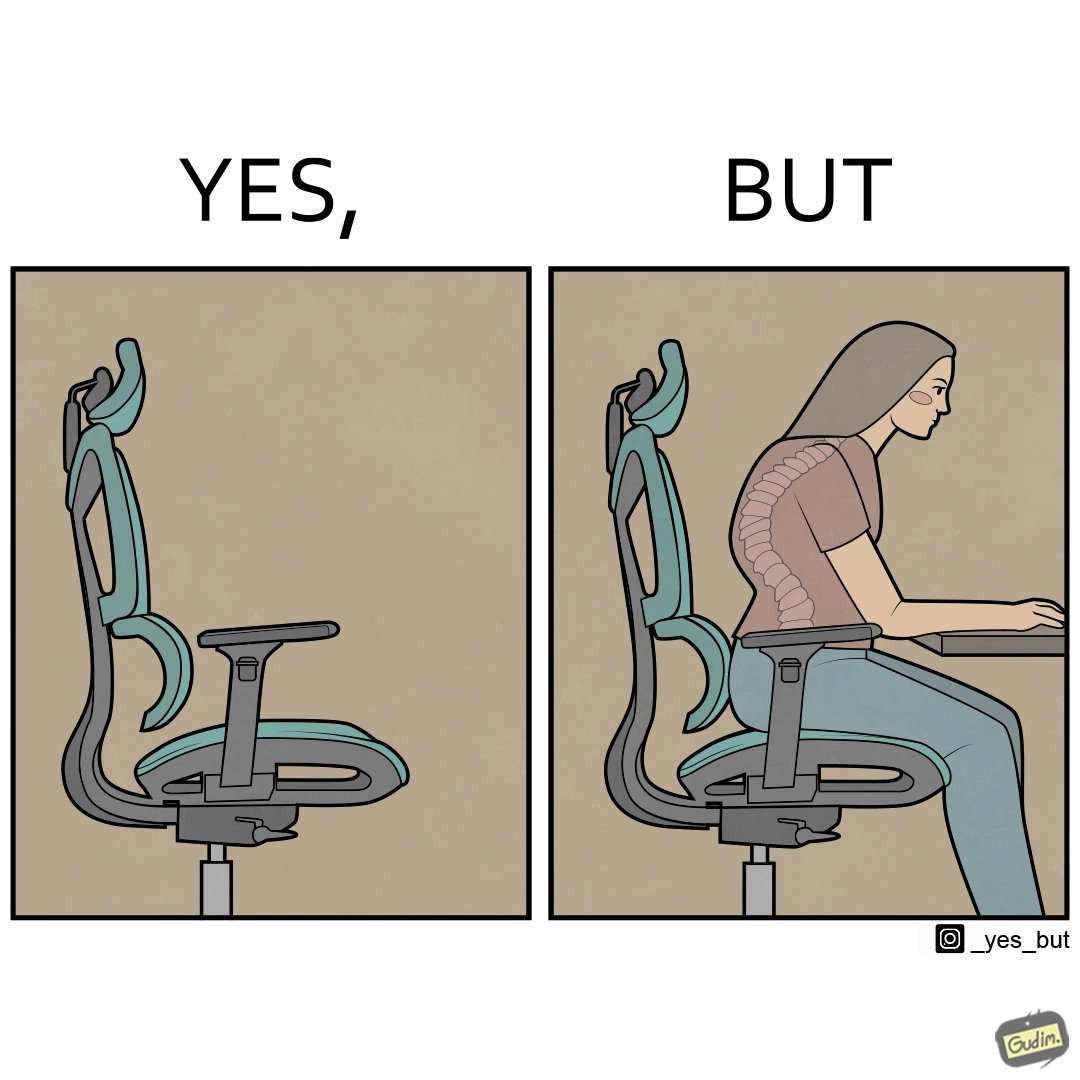Describe the satirical element in this image. The image is ironical, as even though the ergonomic chair is meant to facilitate an upright and comfortable posture for the person sitting on it, the person sitting on it still has a bent posture, as the person is not utilizing the backrest. 